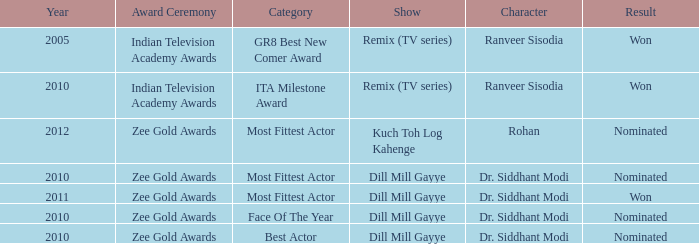Which show was nominated for the ITA Milestone Award at the Indian Television Academy Awards? Remix (TV series). 